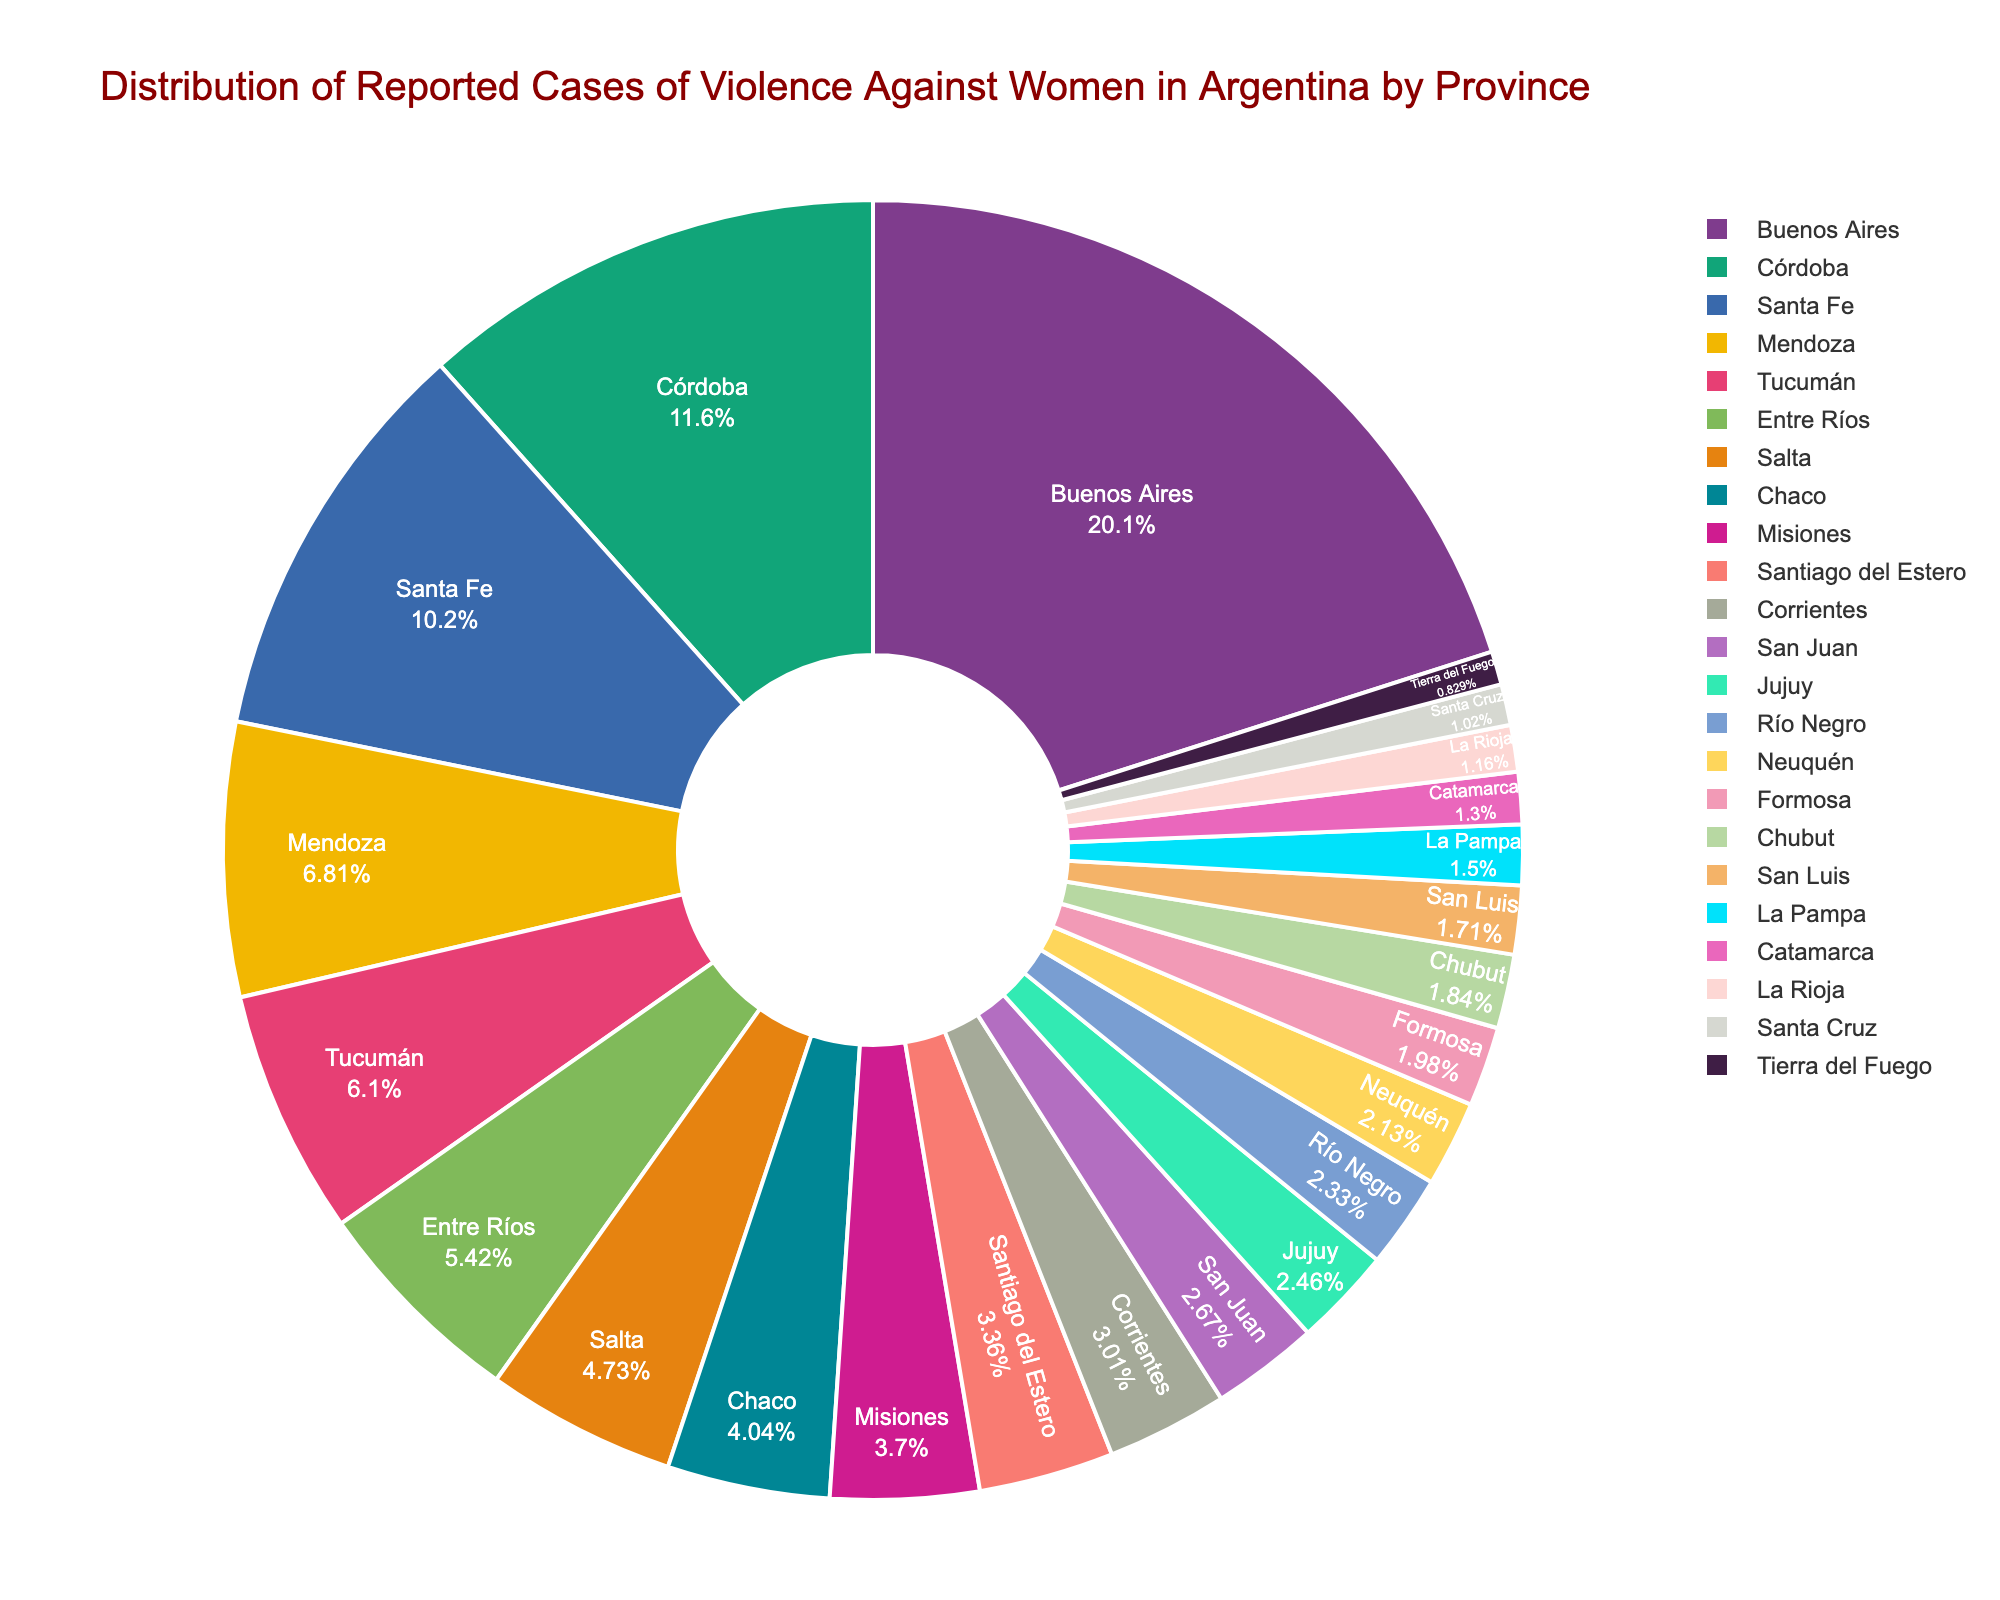What's the province with the highest number of reported cases of violence against women? Look for the largest section of the pie chart and check the label associated with it. Based on the size and label, Buenos Aires has the highest number of reported cases.
Answer: Buenos Aires Which three provinces have the lowest number of reported cases? Examine the smallest slices of the pie chart and identify their labels. The three smallest slices are for Tierra del Fuego, Santa Cruz, and La Rioja.
Answer: Tierra del Fuego, Santa Cruz, La Rioja How many more reported cases are there in Buenos Aires compared to Córdoba? Subtract the reported cases in Córdoba from those in Buenos Aires: 3245 (Buenos Aires) - 1876 (Córdoba) = 1369.
Answer: 1369 Which province has almost half the cases reported in Buenos Aires? Compare the slices to find a province with reported cases close to half of Buenos Aires. Córdoba has just over half of Buenos Aires' reported cases. 1876 is slightly above half of 3245.
Answer: Córdoba Does Santa Fe have more or fewer reported cases than Mendoza and Tucumán combined? Sum the reported cases of Mendoza and Tucumán: 1102 (Mendoza) + 987 (Tucumán) = 2089. Compare this total to Santa Fe's reported cases: 1654. Santa Fe has fewer cases.
Answer: Fewer What is the approximate percentage of reported cases in Buenos Aires out of the total? Find Buenos Aires' reported cases (3245) and sum all reported cases across provinces. Buenos Aires cases: 3245. Total cases: 17,315. Percent: (3245 / 17,315) * 100 = 18.74%.
Answer: 18.74% Name two provinces that have a similar number of reported cases. Find two adjacent or similarly-sized slices and compare their values. Santa Fe (1654) and Mendoza (1102) are relatively close in size, but Entre Ríos (876) and Salta (765) are even closer.
Answer: Entre Ríos & Salta Between Tucumán and Chaco, which province has a larger share of reported cases? Compare the sizes of the pie chart slices for Tucumán and Chaco. Tucumán's slice is larger than Chaco's slice.
Answer: Tucumán How many provinces have more than 1500 reported cases? Identify and count labels with values exceeding 1500. Buenos Aires (3245), Córdoba (1876), and Santa Fe (1654) are the only ones above 1500.
Answer: 3 What is the combined contribution (in percentage) of Misiones and Santiago del Estero to the total reported cases? Find the sum of reported cases in both provinces: 598 (Misiones) + 543 (Santiago del Estero) = 1141. Calculate their combined percentage: (1141 / 17,315) * 100 ≈ 6.59%.
Answer: 6.59% 